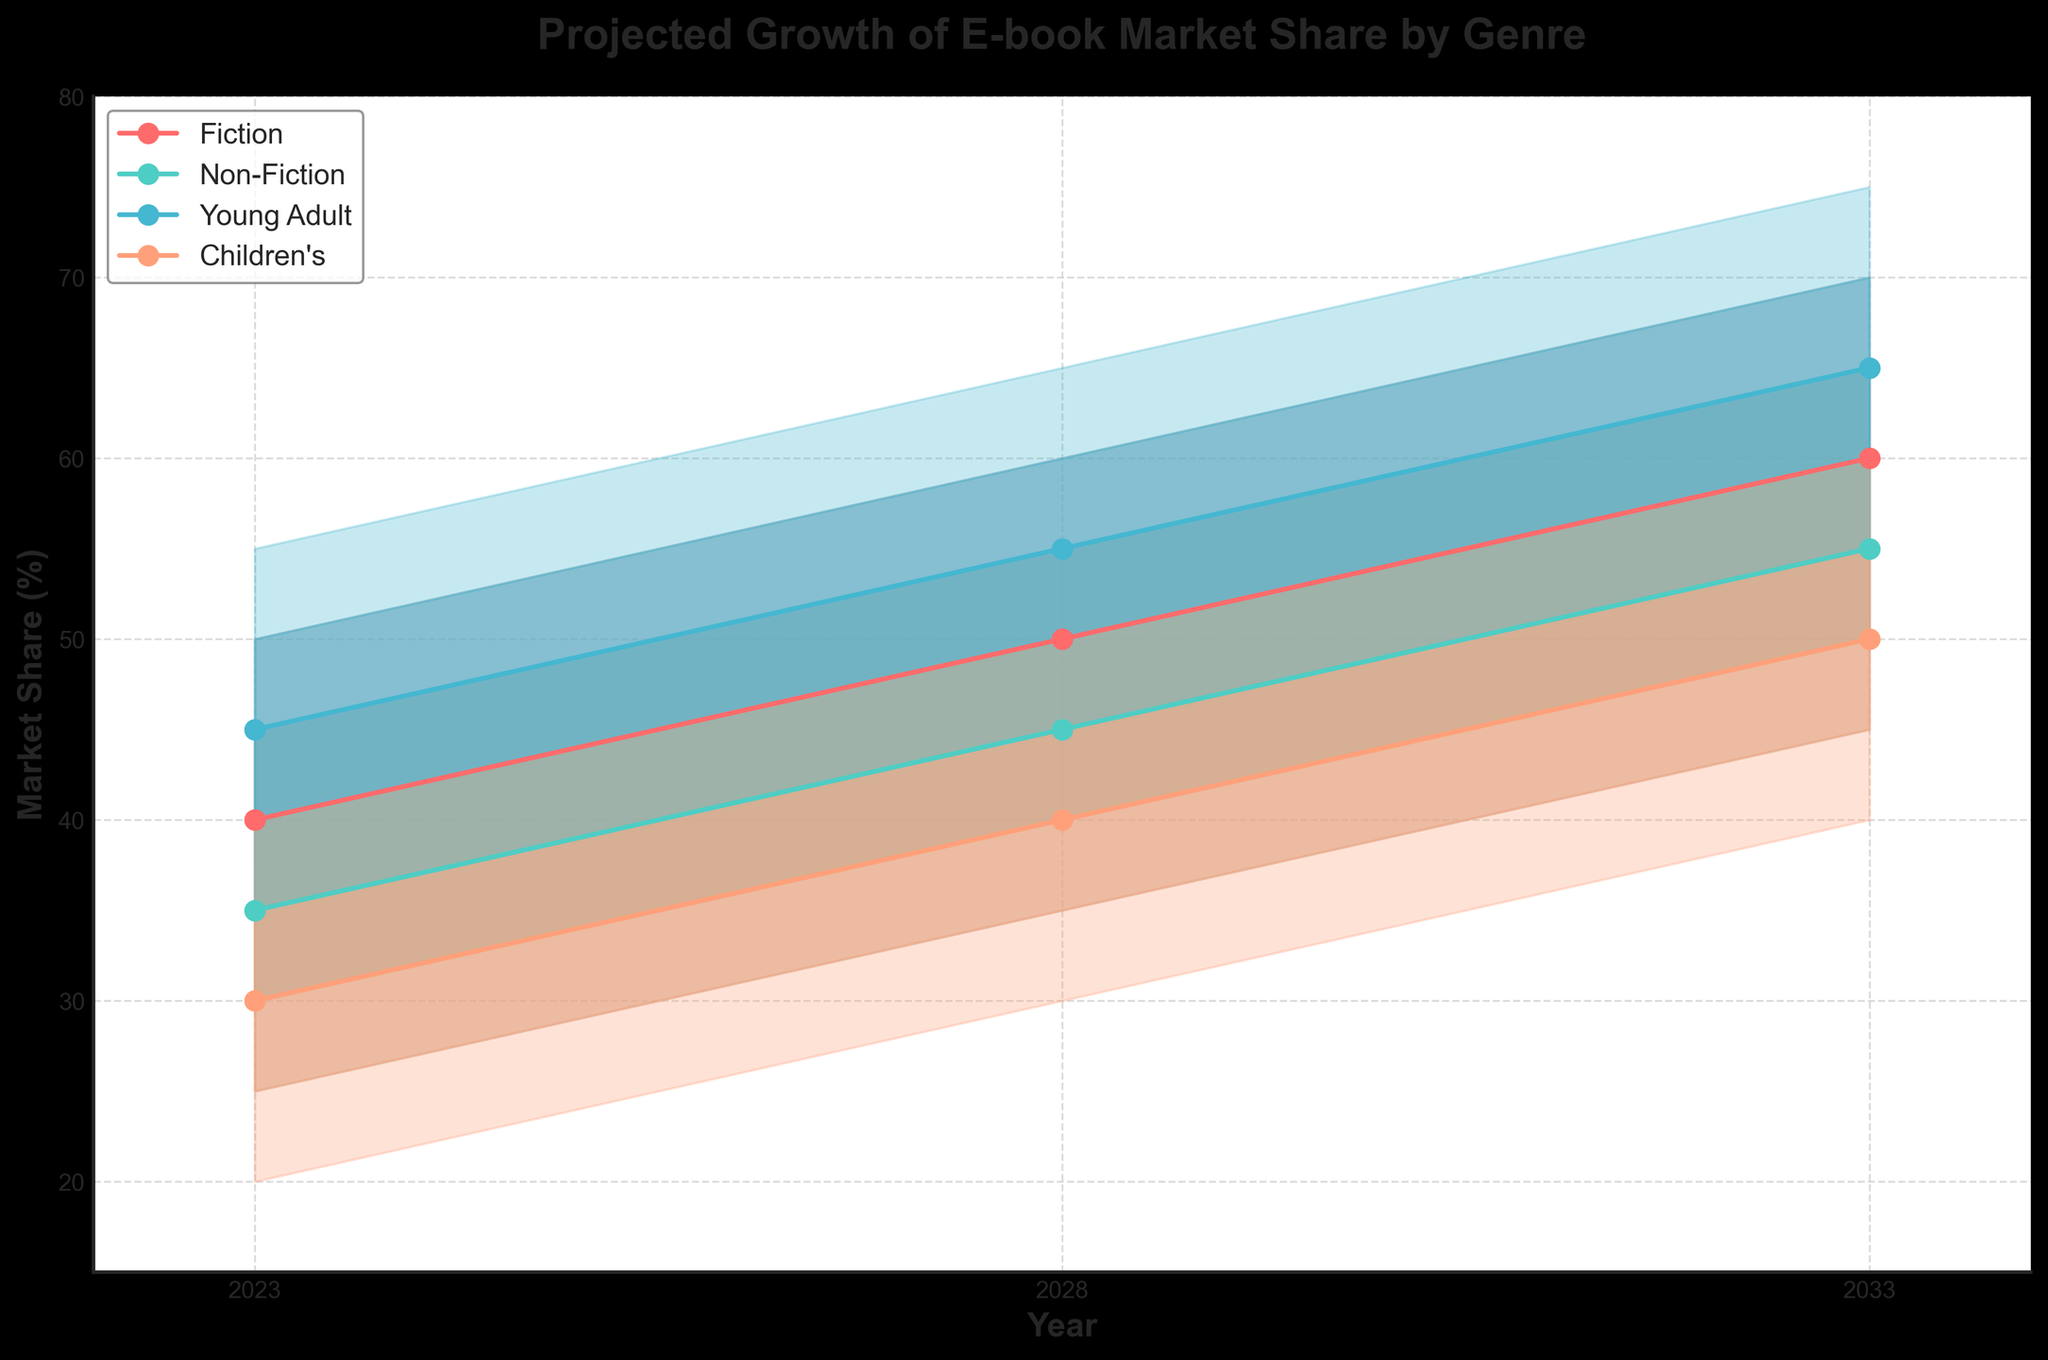What is the projected market share for Fiction e-books in 2033 as per the Medium scenario? To find the projected market share for Fiction e-books in 2033 according to the Medium scenario, look at the value in the Medium column for the year 2033 and the Fiction genre. This value is 60%.
Answer: 60% Which genre has the highest projected market share in 2023 according to the High estimate? Look at the High column for the year 2023 and compare the values for all genres. Young Adult has the highest value of 55%.
Answer: Young Adult What is the average projected market share for Non-Fiction e-books in 2028 across all scenarios? Add the values from all scenarios for Non-Fiction in 2028 and divide by the number of scenarios: (35 + 40 + 45 + 50 + 55) / 5 = 45%.
Answer: 45% How much does the projected market share for Children's e-books increase from 2023 to 2033 in the Medium scenario? Subtract the Medium scenario value for 2023 from the corresponding 2033 value for Children's e-books: 50% - 30% = 20%.
Answer: 20% Which year shows the smallest difference between the Low and High projections for Young Adult e-books? Calculate the difference between the Low and High values for each year for Young Adult. The smallest difference is in 2023 (55% - 35% = 20%).
Answer: 2023 Is the projected growth of Young Adult e-books consistent across all scenarios? Compare the intervals (Low to High) for Young Adult e-books across the years. Each interval increases consistently, indicating steady growth across all scenarios.
Answer: Yes What is the range of projected market share for Fiction e-books in 2028? The range is the difference between the High and Low values for Fiction in 2028: 60% - 40% = 20%.
Answer: 20% In which genre is the projected growth from 2023 to 2033 the greatest? Calculate the difference in the High values from 2023 to 2033 for each genre. Fiction has the greatest increase: 70% - 50% = 20%.
Answer: Fiction 